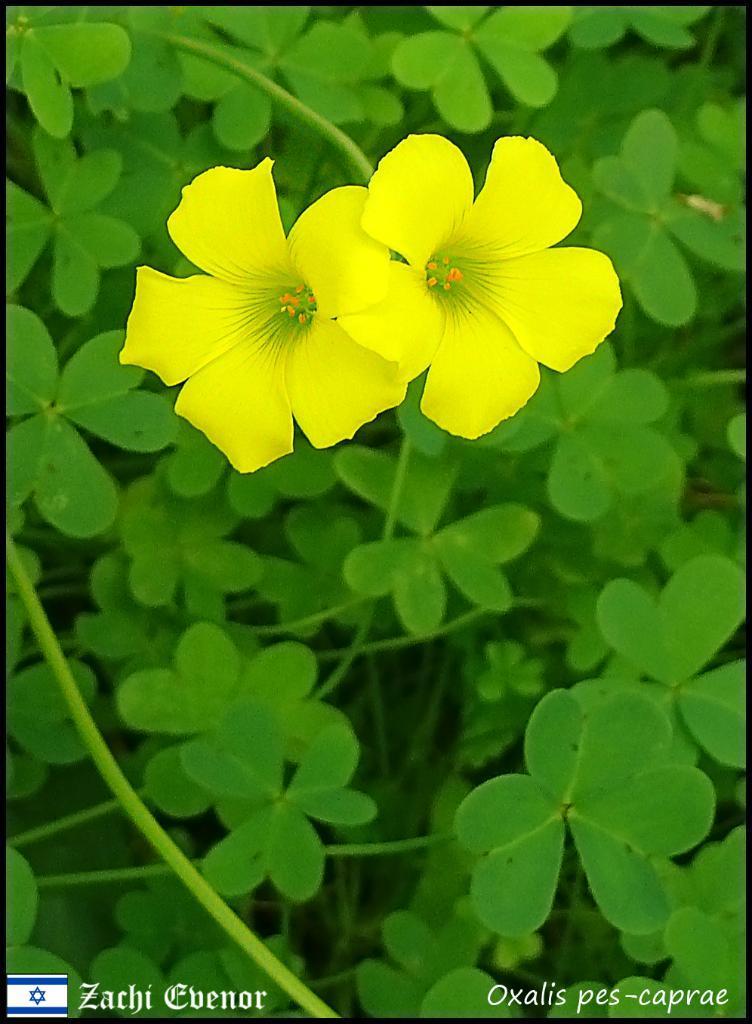Can you describe this image briefly? In this image there are two yellow flowers. In the background there are plants. 